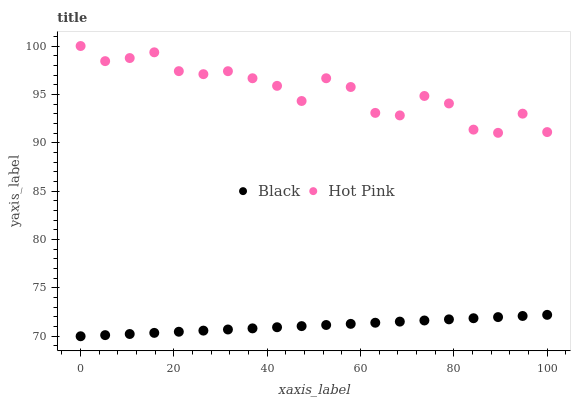Does Black have the minimum area under the curve?
Answer yes or no. Yes. Does Hot Pink have the maximum area under the curve?
Answer yes or no. Yes. Does Black have the maximum area under the curve?
Answer yes or no. No. Is Black the smoothest?
Answer yes or no. Yes. Is Hot Pink the roughest?
Answer yes or no. Yes. Is Black the roughest?
Answer yes or no. No. Does Black have the lowest value?
Answer yes or no. Yes. Does Hot Pink have the highest value?
Answer yes or no. Yes. Does Black have the highest value?
Answer yes or no. No. Is Black less than Hot Pink?
Answer yes or no. Yes. Is Hot Pink greater than Black?
Answer yes or no. Yes. Does Black intersect Hot Pink?
Answer yes or no. No. 